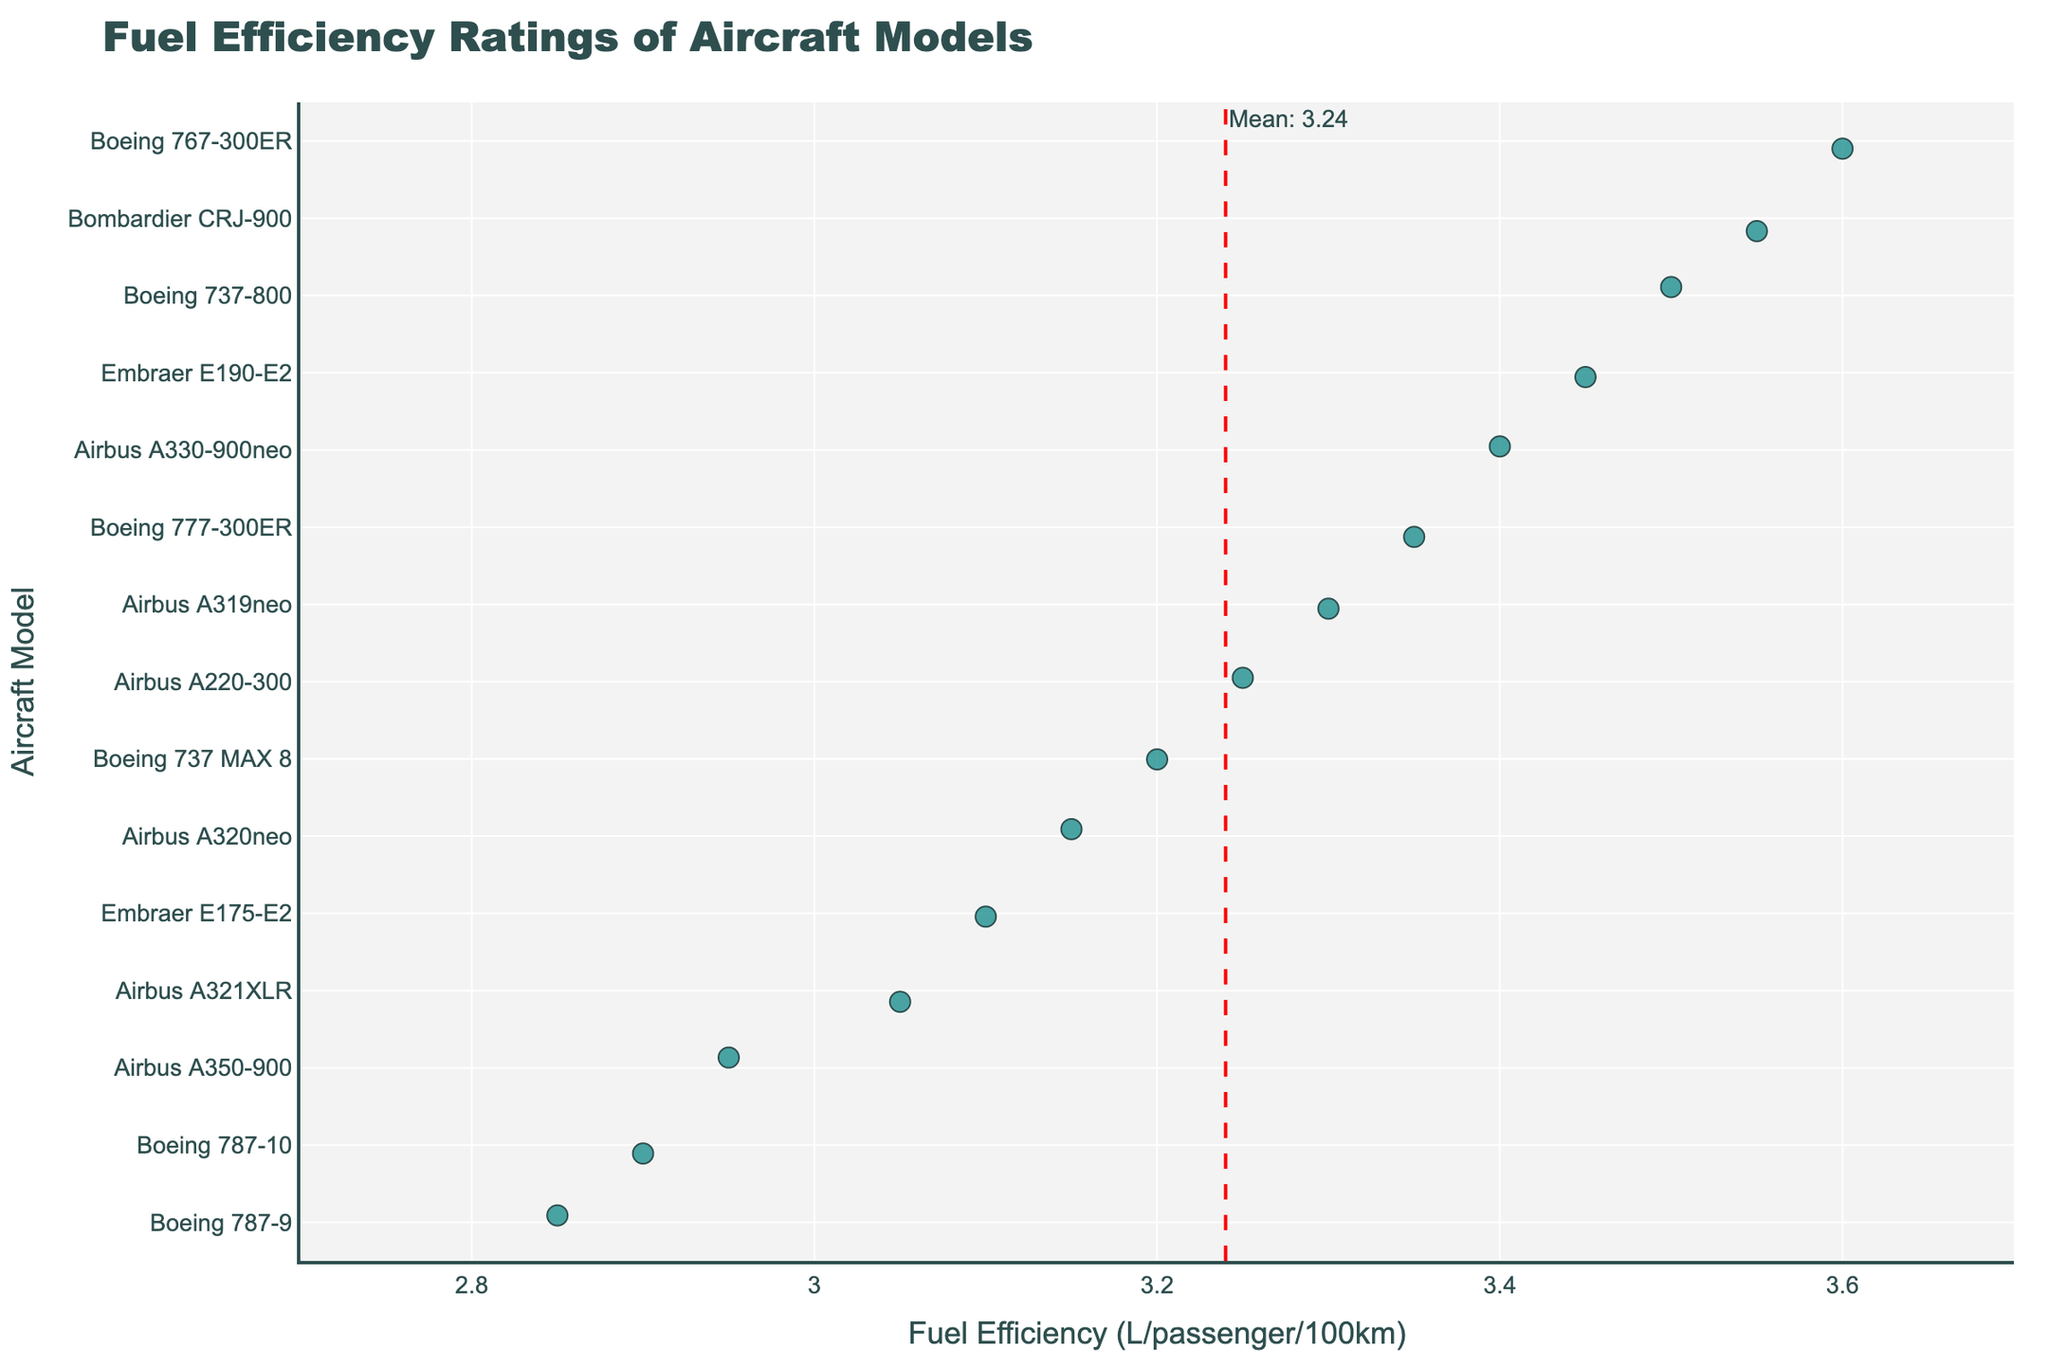What's the title of the plot? The title is displayed at the top of the plot, indicating the subject of the plot.
Answer: Fuel Efficiency Ratings of Aircraft Models What are the axes of the plot? The plot shows the 'Fuel Efficiency (liters per passenger per 100km)' on the x-axis and 'Aircraft Model' on the y-axis.
Answer: x-axis: Fuel Efficiency (liters per passenger per 100km), y-axis: Aircraft Model Which aircraft model has the highest fuel efficiency? The aircraft model with the lowest value on the x-axis (Fuel Efficiency) represents the highest efficiency. The Boeing 787-9 is at the lowest end of the x-axis.
Answer: Boeing 787-9 How many aircraft models have a fuel efficiency rating below 3.0? Count the number of data points on the x-axis that are less than 3.0. These points are Boeing 787-9, Airbus A350-900, Boeing 787-10. There are 3 models.
Answer: 3 What is the mean fuel efficiency of the aircraft models? The mean efficiency is marked by a vertical red dashed line annotated with the mean value.
Answer: Approximately 3.24 Is the Airbus A321XLR more efficient than the Airbus A320neo? Compare the x-axis positions of Airbus A321XLR and Airbus A320neo; Airbus A321XLR is at 3.05, which is less than 3.15 of Airbus A320neo.
Answer: Yes Which aircraft model has the second-highest fuel efficiency? The second-lowest value on the x-axis represents the second-highest efficiency, which is for the Boeing 787-10.
Answer: Boeing 787-10 What is the fuel efficiency range of the aircraft models? Subtract the lowest fuel efficiency value (2.85 for Boeing 787-9) from the highest (3.60 for Boeing 767-300ER). 3.60 - 2.85 = 0.75.
Answer: 0.75 How does the fuel efficiency of the Boeing 737 MAX 8 compare to the mean? The Boeing 737 MAX 8 has a fuel efficiency value of 3.20, which we compare to the mean value of approximately 3.24.
Answer: It's slightly better than the mean Which aircraft model has a fuel efficiency rating closest to the mean? Compare each aircraft's fuel efficiency to the mean value (3.24); the Airbus A319neo has 3.30, which is nearest.
Answer: Airbus A319neo 